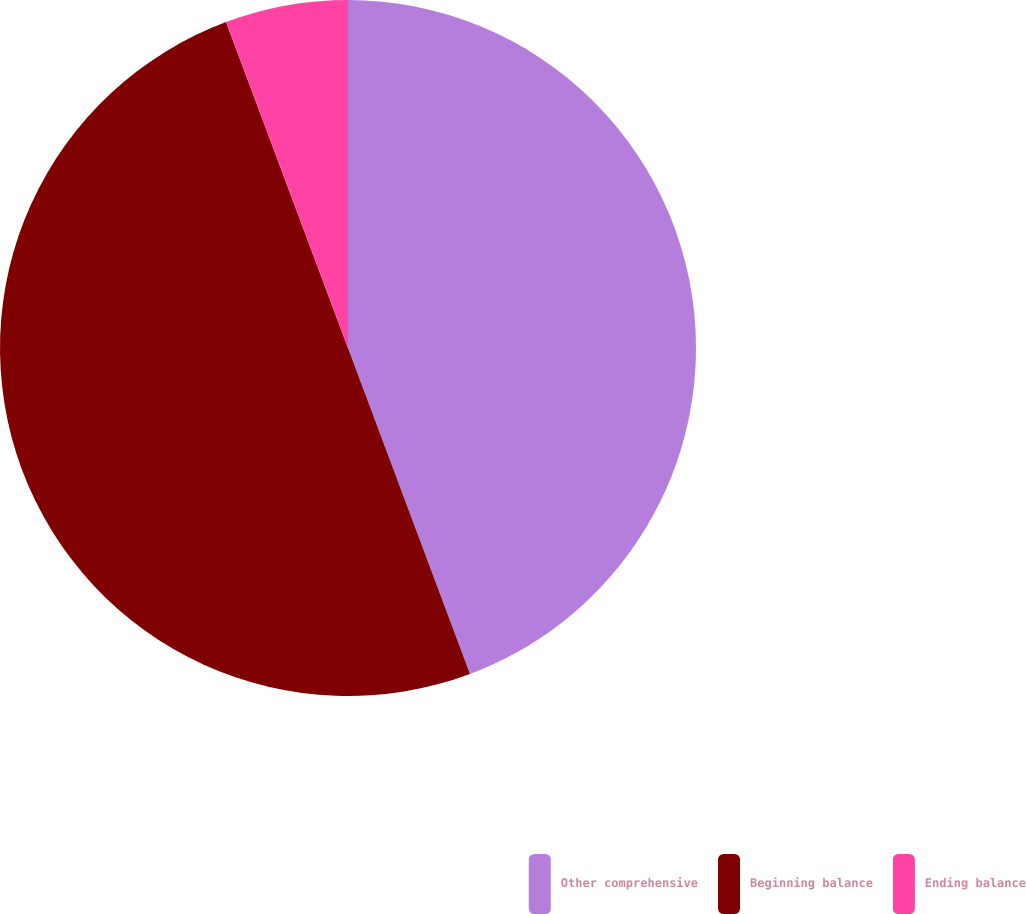Convert chart. <chart><loc_0><loc_0><loc_500><loc_500><pie_chart><fcel>Other comprehensive<fcel>Beginning balance<fcel>Ending balance<nl><fcel>44.3%<fcel>50.0%<fcel>5.7%<nl></chart> 